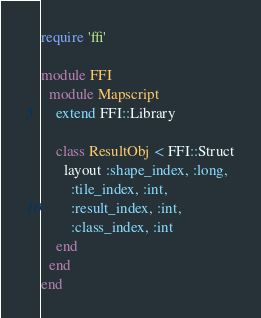<code> <loc_0><loc_0><loc_500><loc_500><_Ruby_>require 'ffi'

module FFI
  module Mapscript
    extend FFI::Library
      
    class ResultObj < FFI::Struct
      layout :shape_index, :long,
        :tile_index, :int,
        :result_index, :int,
        :class_index, :int
    end
  end
end
</code> 